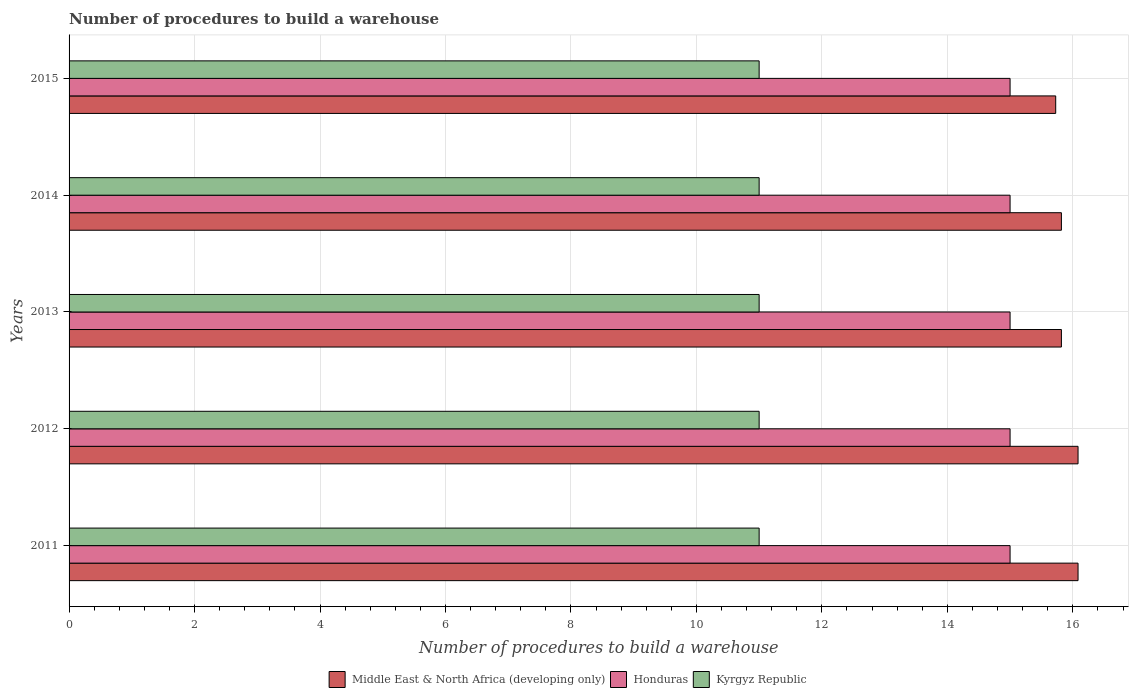Are the number of bars on each tick of the Y-axis equal?
Your answer should be very brief. Yes. How many bars are there on the 2nd tick from the bottom?
Ensure brevity in your answer.  3. What is the label of the 1st group of bars from the top?
Make the answer very short. 2015. What is the number of procedures to build a warehouse in in Middle East & North Africa (developing only) in 2012?
Ensure brevity in your answer.  16.08. Across all years, what is the maximum number of procedures to build a warehouse in in Middle East & North Africa (developing only)?
Give a very brief answer. 16.08. Across all years, what is the minimum number of procedures to build a warehouse in in Honduras?
Make the answer very short. 15. In which year was the number of procedures to build a warehouse in in Middle East & North Africa (developing only) maximum?
Provide a short and direct response. 2011. In which year was the number of procedures to build a warehouse in in Kyrgyz Republic minimum?
Make the answer very short. 2011. What is the total number of procedures to build a warehouse in in Middle East & North Africa (developing only) in the graph?
Your response must be concise. 79.53. What is the difference between the number of procedures to build a warehouse in in Middle East & North Africa (developing only) in 2013 and that in 2015?
Offer a terse response. 0.09. What is the difference between the number of procedures to build a warehouse in in Middle East & North Africa (developing only) in 2015 and the number of procedures to build a warehouse in in Honduras in 2012?
Your response must be concise. 0.73. In the year 2012, what is the difference between the number of procedures to build a warehouse in in Honduras and number of procedures to build a warehouse in in Kyrgyz Republic?
Your answer should be very brief. 4. What is the ratio of the number of procedures to build a warehouse in in Middle East & North Africa (developing only) in 2012 to that in 2015?
Provide a short and direct response. 1.02. What is the difference between the highest and the second highest number of procedures to build a warehouse in in Middle East & North Africa (developing only)?
Provide a short and direct response. 0. What is the difference between the highest and the lowest number of procedures to build a warehouse in in Middle East & North Africa (developing only)?
Make the answer very short. 0.36. What does the 2nd bar from the top in 2015 represents?
Make the answer very short. Honduras. What does the 1st bar from the bottom in 2013 represents?
Your response must be concise. Middle East & North Africa (developing only). Is it the case that in every year, the sum of the number of procedures to build a warehouse in in Middle East & North Africa (developing only) and number of procedures to build a warehouse in in Honduras is greater than the number of procedures to build a warehouse in in Kyrgyz Republic?
Your answer should be compact. Yes. How many bars are there?
Make the answer very short. 15. Are all the bars in the graph horizontal?
Provide a succinct answer. Yes. How many years are there in the graph?
Ensure brevity in your answer.  5. What is the difference between two consecutive major ticks on the X-axis?
Provide a short and direct response. 2. Are the values on the major ticks of X-axis written in scientific E-notation?
Give a very brief answer. No. Does the graph contain any zero values?
Provide a short and direct response. No. How many legend labels are there?
Your answer should be very brief. 3. How are the legend labels stacked?
Keep it short and to the point. Horizontal. What is the title of the graph?
Make the answer very short. Number of procedures to build a warehouse. Does "Kazakhstan" appear as one of the legend labels in the graph?
Provide a short and direct response. No. What is the label or title of the X-axis?
Keep it short and to the point. Number of procedures to build a warehouse. What is the label or title of the Y-axis?
Provide a succinct answer. Years. What is the Number of procedures to build a warehouse of Middle East & North Africa (developing only) in 2011?
Your answer should be very brief. 16.08. What is the Number of procedures to build a warehouse in Honduras in 2011?
Give a very brief answer. 15. What is the Number of procedures to build a warehouse in Kyrgyz Republic in 2011?
Offer a very short reply. 11. What is the Number of procedures to build a warehouse of Middle East & North Africa (developing only) in 2012?
Your answer should be very brief. 16.08. What is the Number of procedures to build a warehouse of Kyrgyz Republic in 2012?
Make the answer very short. 11. What is the Number of procedures to build a warehouse in Middle East & North Africa (developing only) in 2013?
Keep it short and to the point. 15.82. What is the Number of procedures to build a warehouse in Honduras in 2013?
Your response must be concise. 15. What is the Number of procedures to build a warehouse in Kyrgyz Republic in 2013?
Your answer should be very brief. 11. What is the Number of procedures to build a warehouse of Middle East & North Africa (developing only) in 2014?
Keep it short and to the point. 15.82. What is the Number of procedures to build a warehouse of Kyrgyz Republic in 2014?
Your response must be concise. 11. What is the Number of procedures to build a warehouse of Middle East & North Africa (developing only) in 2015?
Provide a short and direct response. 15.73. What is the Number of procedures to build a warehouse in Honduras in 2015?
Your response must be concise. 15. What is the Number of procedures to build a warehouse of Kyrgyz Republic in 2015?
Make the answer very short. 11. Across all years, what is the maximum Number of procedures to build a warehouse of Middle East & North Africa (developing only)?
Keep it short and to the point. 16.08. Across all years, what is the maximum Number of procedures to build a warehouse in Honduras?
Your answer should be compact. 15. Across all years, what is the maximum Number of procedures to build a warehouse in Kyrgyz Republic?
Your answer should be compact. 11. Across all years, what is the minimum Number of procedures to build a warehouse in Middle East & North Africa (developing only)?
Offer a terse response. 15.73. Across all years, what is the minimum Number of procedures to build a warehouse of Kyrgyz Republic?
Your answer should be compact. 11. What is the total Number of procedures to build a warehouse in Middle East & North Africa (developing only) in the graph?
Your answer should be compact. 79.53. What is the difference between the Number of procedures to build a warehouse in Middle East & North Africa (developing only) in 2011 and that in 2013?
Make the answer very short. 0.27. What is the difference between the Number of procedures to build a warehouse of Middle East & North Africa (developing only) in 2011 and that in 2014?
Offer a very short reply. 0.27. What is the difference between the Number of procedures to build a warehouse in Kyrgyz Republic in 2011 and that in 2014?
Your answer should be compact. 0. What is the difference between the Number of procedures to build a warehouse of Middle East & North Africa (developing only) in 2011 and that in 2015?
Your answer should be compact. 0.36. What is the difference between the Number of procedures to build a warehouse of Honduras in 2011 and that in 2015?
Provide a succinct answer. 0. What is the difference between the Number of procedures to build a warehouse of Kyrgyz Republic in 2011 and that in 2015?
Your response must be concise. 0. What is the difference between the Number of procedures to build a warehouse in Middle East & North Africa (developing only) in 2012 and that in 2013?
Ensure brevity in your answer.  0.27. What is the difference between the Number of procedures to build a warehouse of Honduras in 2012 and that in 2013?
Ensure brevity in your answer.  0. What is the difference between the Number of procedures to build a warehouse in Kyrgyz Republic in 2012 and that in 2013?
Provide a succinct answer. 0. What is the difference between the Number of procedures to build a warehouse in Middle East & North Africa (developing only) in 2012 and that in 2014?
Provide a short and direct response. 0.27. What is the difference between the Number of procedures to build a warehouse in Kyrgyz Republic in 2012 and that in 2014?
Your response must be concise. 0. What is the difference between the Number of procedures to build a warehouse of Middle East & North Africa (developing only) in 2012 and that in 2015?
Keep it short and to the point. 0.36. What is the difference between the Number of procedures to build a warehouse of Honduras in 2012 and that in 2015?
Provide a short and direct response. 0. What is the difference between the Number of procedures to build a warehouse in Kyrgyz Republic in 2012 and that in 2015?
Provide a short and direct response. 0. What is the difference between the Number of procedures to build a warehouse in Middle East & North Africa (developing only) in 2013 and that in 2014?
Offer a very short reply. 0. What is the difference between the Number of procedures to build a warehouse of Middle East & North Africa (developing only) in 2013 and that in 2015?
Ensure brevity in your answer.  0.09. What is the difference between the Number of procedures to build a warehouse of Honduras in 2013 and that in 2015?
Your response must be concise. 0. What is the difference between the Number of procedures to build a warehouse in Kyrgyz Republic in 2013 and that in 2015?
Offer a very short reply. 0. What is the difference between the Number of procedures to build a warehouse in Middle East & North Africa (developing only) in 2014 and that in 2015?
Ensure brevity in your answer.  0.09. What is the difference between the Number of procedures to build a warehouse in Honduras in 2014 and that in 2015?
Offer a very short reply. 0. What is the difference between the Number of procedures to build a warehouse of Kyrgyz Republic in 2014 and that in 2015?
Your answer should be very brief. 0. What is the difference between the Number of procedures to build a warehouse in Middle East & North Africa (developing only) in 2011 and the Number of procedures to build a warehouse in Kyrgyz Republic in 2012?
Provide a short and direct response. 5.08. What is the difference between the Number of procedures to build a warehouse in Honduras in 2011 and the Number of procedures to build a warehouse in Kyrgyz Republic in 2012?
Give a very brief answer. 4. What is the difference between the Number of procedures to build a warehouse of Middle East & North Africa (developing only) in 2011 and the Number of procedures to build a warehouse of Honduras in 2013?
Ensure brevity in your answer.  1.08. What is the difference between the Number of procedures to build a warehouse in Middle East & North Africa (developing only) in 2011 and the Number of procedures to build a warehouse in Kyrgyz Republic in 2013?
Offer a very short reply. 5.08. What is the difference between the Number of procedures to build a warehouse in Honduras in 2011 and the Number of procedures to build a warehouse in Kyrgyz Republic in 2013?
Make the answer very short. 4. What is the difference between the Number of procedures to build a warehouse in Middle East & North Africa (developing only) in 2011 and the Number of procedures to build a warehouse in Honduras in 2014?
Your answer should be very brief. 1.08. What is the difference between the Number of procedures to build a warehouse in Middle East & North Africa (developing only) in 2011 and the Number of procedures to build a warehouse in Kyrgyz Republic in 2014?
Your answer should be compact. 5.08. What is the difference between the Number of procedures to build a warehouse of Middle East & North Africa (developing only) in 2011 and the Number of procedures to build a warehouse of Kyrgyz Republic in 2015?
Offer a terse response. 5.08. What is the difference between the Number of procedures to build a warehouse in Middle East & North Africa (developing only) in 2012 and the Number of procedures to build a warehouse in Kyrgyz Republic in 2013?
Your answer should be very brief. 5.08. What is the difference between the Number of procedures to build a warehouse in Middle East & North Africa (developing only) in 2012 and the Number of procedures to build a warehouse in Kyrgyz Republic in 2014?
Your answer should be compact. 5.08. What is the difference between the Number of procedures to build a warehouse of Honduras in 2012 and the Number of procedures to build a warehouse of Kyrgyz Republic in 2014?
Offer a terse response. 4. What is the difference between the Number of procedures to build a warehouse of Middle East & North Africa (developing only) in 2012 and the Number of procedures to build a warehouse of Kyrgyz Republic in 2015?
Make the answer very short. 5.08. What is the difference between the Number of procedures to build a warehouse in Honduras in 2012 and the Number of procedures to build a warehouse in Kyrgyz Republic in 2015?
Your answer should be compact. 4. What is the difference between the Number of procedures to build a warehouse of Middle East & North Africa (developing only) in 2013 and the Number of procedures to build a warehouse of Honduras in 2014?
Offer a very short reply. 0.82. What is the difference between the Number of procedures to build a warehouse of Middle East & North Africa (developing only) in 2013 and the Number of procedures to build a warehouse of Kyrgyz Republic in 2014?
Keep it short and to the point. 4.82. What is the difference between the Number of procedures to build a warehouse of Honduras in 2013 and the Number of procedures to build a warehouse of Kyrgyz Republic in 2014?
Give a very brief answer. 4. What is the difference between the Number of procedures to build a warehouse of Middle East & North Africa (developing only) in 2013 and the Number of procedures to build a warehouse of Honduras in 2015?
Ensure brevity in your answer.  0.82. What is the difference between the Number of procedures to build a warehouse in Middle East & North Africa (developing only) in 2013 and the Number of procedures to build a warehouse in Kyrgyz Republic in 2015?
Make the answer very short. 4.82. What is the difference between the Number of procedures to build a warehouse of Honduras in 2013 and the Number of procedures to build a warehouse of Kyrgyz Republic in 2015?
Your response must be concise. 4. What is the difference between the Number of procedures to build a warehouse in Middle East & North Africa (developing only) in 2014 and the Number of procedures to build a warehouse in Honduras in 2015?
Offer a terse response. 0.82. What is the difference between the Number of procedures to build a warehouse of Middle East & North Africa (developing only) in 2014 and the Number of procedures to build a warehouse of Kyrgyz Republic in 2015?
Keep it short and to the point. 4.82. What is the difference between the Number of procedures to build a warehouse in Honduras in 2014 and the Number of procedures to build a warehouse in Kyrgyz Republic in 2015?
Ensure brevity in your answer.  4. What is the average Number of procedures to build a warehouse of Middle East & North Africa (developing only) per year?
Offer a terse response. 15.91. What is the average Number of procedures to build a warehouse of Honduras per year?
Offer a very short reply. 15. What is the average Number of procedures to build a warehouse in Kyrgyz Republic per year?
Provide a succinct answer. 11. In the year 2011, what is the difference between the Number of procedures to build a warehouse in Middle East & North Africa (developing only) and Number of procedures to build a warehouse in Kyrgyz Republic?
Keep it short and to the point. 5.08. In the year 2011, what is the difference between the Number of procedures to build a warehouse in Honduras and Number of procedures to build a warehouse in Kyrgyz Republic?
Your answer should be compact. 4. In the year 2012, what is the difference between the Number of procedures to build a warehouse of Middle East & North Africa (developing only) and Number of procedures to build a warehouse of Honduras?
Make the answer very short. 1.08. In the year 2012, what is the difference between the Number of procedures to build a warehouse of Middle East & North Africa (developing only) and Number of procedures to build a warehouse of Kyrgyz Republic?
Make the answer very short. 5.08. In the year 2012, what is the difference between the Number of procedures to build a warehouse in Honduras and Number of procedures to build a warehouse in Kyrgyz Republic?
Your response must be concise. 4. In the year 2013, what is the difference between the Number of procedures to build a warehouse of Middle East & North Africa (developing only) and Number of procedures to build a warehouse of Honduras?
Make the answer very short. 0.82. In the year 2013, what is the difference between the Number of procedures to build a warehouse of Middle East & North Africa (developing only) and Number of procedures to build a warehouse of Kyrgyz Republic?
Make the answer very short. 4.82. In the year 2014, what is the difference between the Number of procedures to build a warehouse in Middle East & North Africa (developing only) and Number of procedures to build a warehouse in Honduras?
Provide a short and direct response. 0.82. In the year 2014, what is the difference between the Number of procedures to build a warehouse in Middle East & North Africa (developing only) and Number of procedures to build a warehouse in Kyrgyz Republic?
Your answer should be compact. 4.82. In the year 2014, what is the difference between the Number of procedures to build a warehouse in Honduras and Number of procedures to build a warehouse in Kyrgyz Republic?
Provide a short and direct response. 4. In the year 2015, what is the difference between the Number of procedures to build a warehouse of Middle East & North Africa (developing only) and Number of procedures to build a warehouse of Honduras?
Your response must be concise. 0.73. In the year 2015, what is the difference between the Number of procedures to build a warehouse of Middle East & North Africa (developing only) and Number of procedures to build a warehouse of Kyrgyz Republic?
Keep it short and to the point. 4.73. What is the ratio of the Number of procedures to build a warehouse of Middle East & North Africa (developing only) in 2011 to that in 2012?
Your response must be concise. 1. What is the ratio of the Number of procedures to build a warehouse in Kyrgyz Republic in 2011 to that in 2012?
Give a very brief answer. 1. What is the ratio of the Number of procedures to build a warehouse in Middle East & North Africa (developing only) in 2011 to that in 2013?
Ensure brevity in your answer.  1.02. What is the ratio of the Number of procedures to build a warehouse of Middle East & North Africa (developing only) in 2011 to that in 2014?
Provide a succinct answer. 1.02. What is the ratio of the Number of procedures to build a warehouse in Honduras in 2011 to that in 2014?
Your answer should be very brief. 1. What is the ratio of the Number of procedures to build a warehouse of Kyrgyz Republic in 2011 to that in 2014?
Make the answer very short. 1. What is the ratio of the Number of procedures to build a warehouse of Middle East & North Africa (developing only) in 2011 to that in 2015?
Offer a very short reply. 1.02. What is the ratio of the Number of procedures to build a warehouse in Honduras in 2011 to that in 2015?
Keep it short and to the point. 1. What is the ratio of the Number of procedures to build a warehouse in Middle East & North Africa (developing only) in 2012 to that in 2013?
Your answer should be compact. 1.02. What is the ratio of the Number of procedures to build a warehouse of Kyrgyz Republic in 2012 to that in 2013?
Provide a succinct answer. 1. What is the ratio of the Number of procedures to build a warehouse of Middle East & North Africa (developing only) in 2012 to that in 2014?
Provide a succinct answer. 1.02. What is the ratio of the Number of procedures to build a warehouse of Kyrgyz Republic in 2012 to that in 2014?
Offer a terse response. 1. What is the ratio of the Number of procedures to build a warehouse in Middle East & North Africa (developing only) in 2012 to that in 2015?
Offer a terse response. 1.02. What is the ratio of the Number of procedures to build a warehouse in Honduras in 2012 to that in 2015?
Your answer should be very brief. 1. What is the ratio of the Number of procedures to build a warehouse in Kyrgyz Republic in 2012 to that in 2015?
Offer a terse response. 1. What is the ratio of the Number of procedures to build a warehouse in Honduras in 2013 to that in 2014?
Your answer should be compact. 1. What is the ratio of the Number of procedures to build a warehouse in Middle East & North Africa (developing only) in 2013 to that in 2015?
Your answer should be very brief. 1.01. What is the ratio of the Number of procedures to build a warehouse of Honduras in 2013 to that in 2015?
Your response must be concise. 1. What is the ratio of the Number of procedures to build a warehouse of Kyrgyz Republic in 2013 to that in 2015?
Offer a terse response. 1. What is the difference between the highest and the second highest Number of procedures to build a warehouse of Middle East & North Africa (developing only)?
Your answer should be compact. 0. What is the difference between the highest and the second highest Number of procedures to build a warehouse in Honduras?
Offer a terse response. 0. What is the difference between the highest and the second highest Number of procedures to build a warehouse in Kyrgyz Republic?
Offer a terse response. 0. What is the difference between the highest and the lowest Number of procedures to build a warehouse in Middle East & North Africa (developing only)?
Your answer should be very brief. 0.36. What is the difference between the highest and the lowest Number of procedures to build a warehouse in Kyrgyz Republic?
Offer a very short reply. 0. 